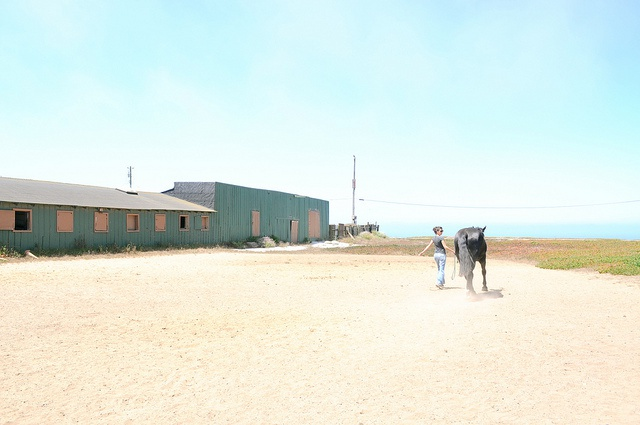Describe the objects in this image and their specific colors. I can see horse in lightblue, darkgray, black, gray, and lightgray tones and people in lightblue, white, darkgray, and tan tones in this image. 